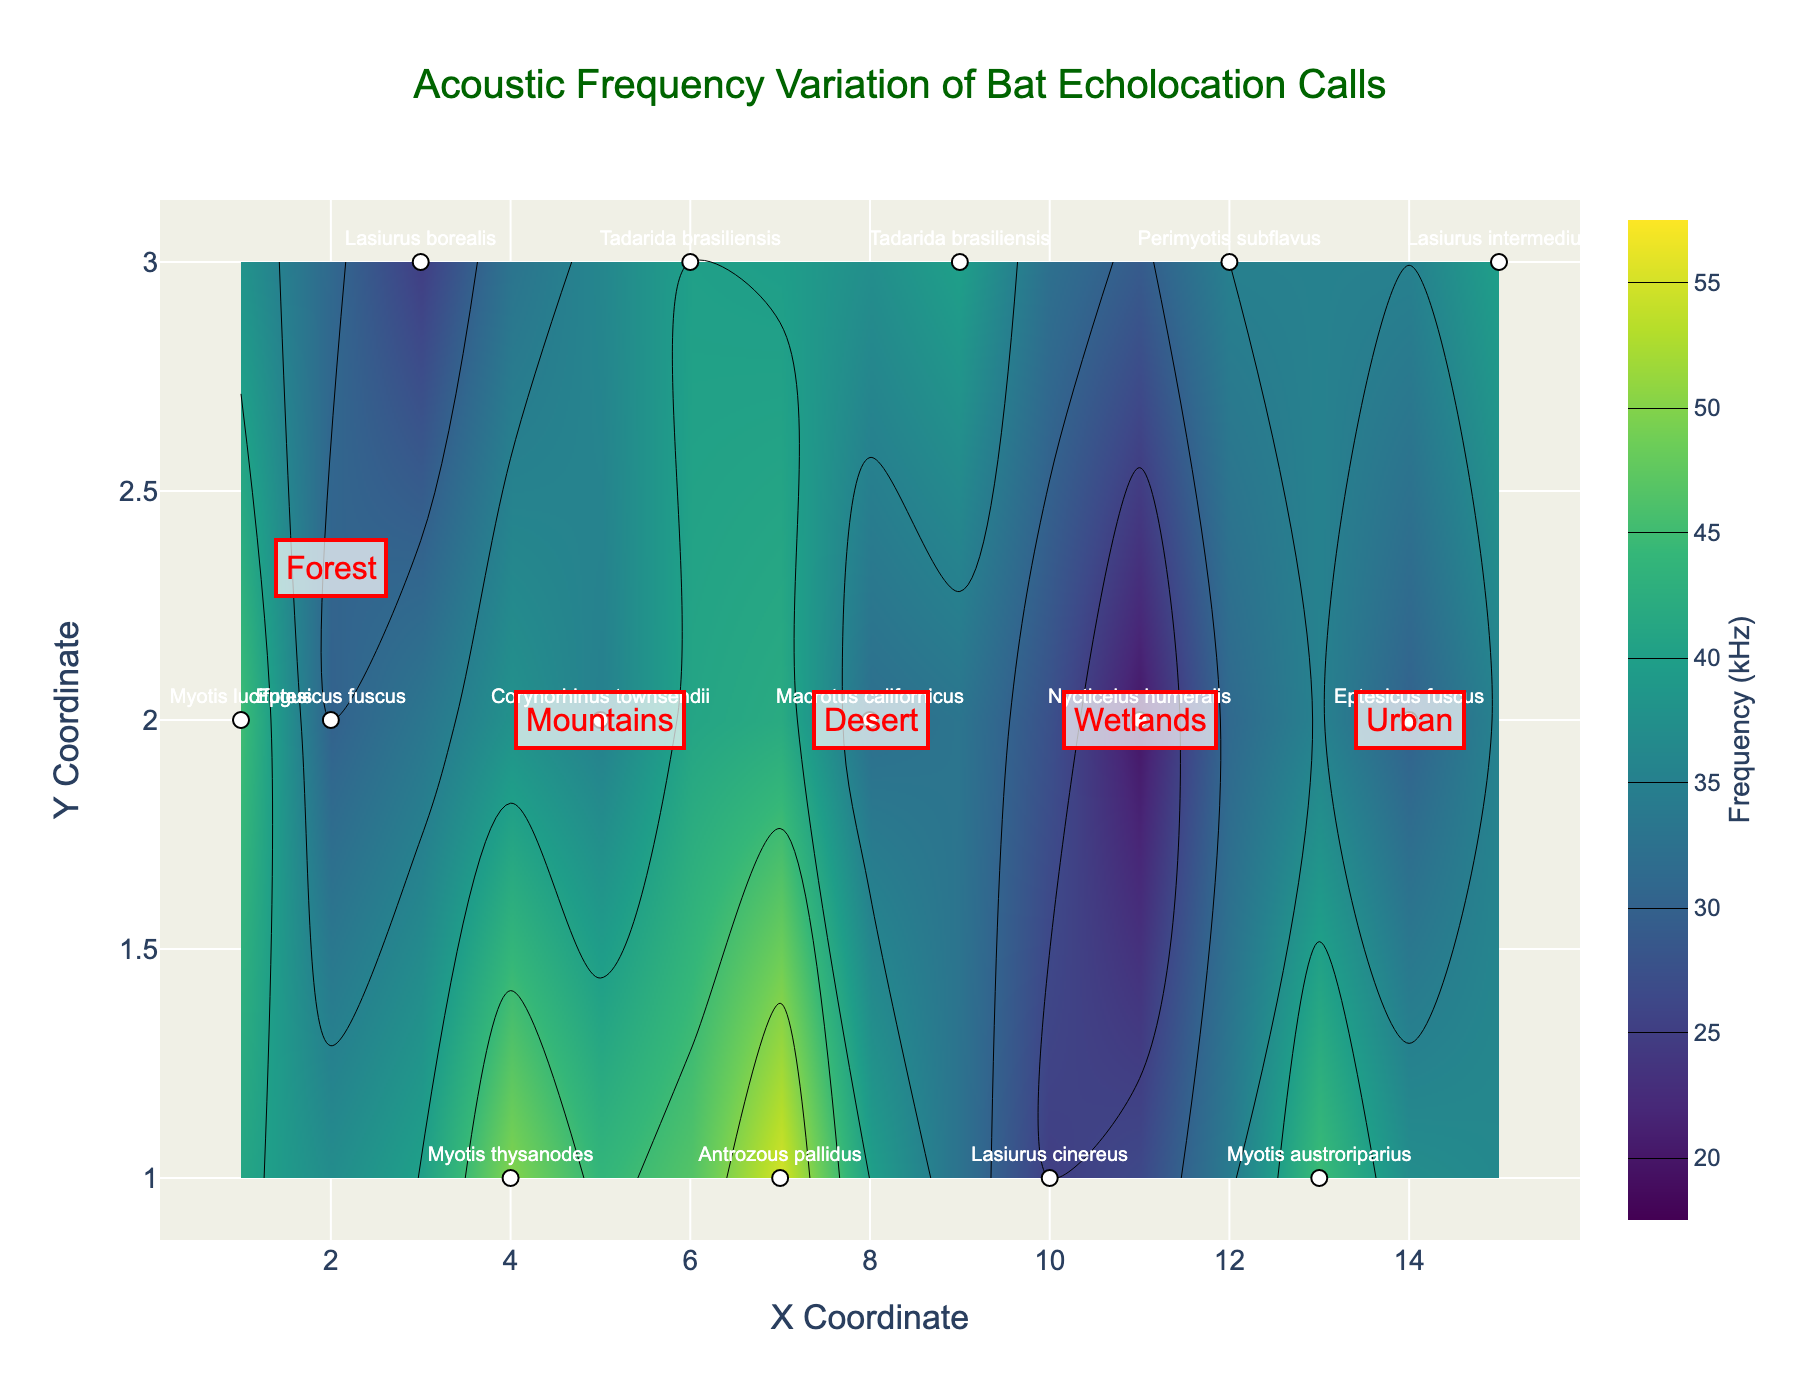What is the title of the figure? The title is located at the top center of the figure, often larger and bold compared to other text. It reads "Acoustic Frequency Variation of Bat Echolocation Calls".
Answer: Acoustic Frequency Variation of Bat Echolocation Calls What is the range of the colorbar? The colorbar is located on the right side of the figure, labeled "Frequency (kHz)", with ticks starting at 20 and ending at 55.
Answer: 20 to 55 kHz Which bat species has the highest acoustic frequency in the mountains terrain? Identify the Mountain region marked on the figure. The species with the highest frequency in this region is Myotis thysanodes, located at the top of the contour lines in this region.
Answer: Myotis thysanodes How many bat species are found in the desert terrain? Look for the Desert annotation in the figure. There are three bat species labeled within this region: Antrozous pallidus, Macrotus californicus, and Tadarida brasiliensis.
Answer: 3 What is the average acoustic frequency of the bat species in the wetlands terrain? Locate the Wetlands region. The frequencies are 25 kHz for Lasiurus cinereus, 20 kHz for Nycticeius humeralis, and 35 kHz for Perimyotis subflavus. Average = (25 + 20 + 35) / 3.
Answer: 26.67 kHz Which terrain has the most varied range of acoustic frequencies among bat species? Compare the range of frequencies in different terrains by looking at the spread of contour lines and the labeled frequencies. The Desert terrain shows a wide range from 32 to 55 kHz.
Answer: Desert Which species can be found in both the Mountains and Desert terrains? Identify the Desert and Mountains regions and compare species names. Tadarida brasiliensis is present in both regions.
Answer: Tadarida brasiliensis At which X and Y coordinates is the species Lasiurus borealis found? Locate the label for Lasiurus borealis in the Forest terrain. Its coordinates are (3, 3).
Answer: (3, 3) What is the difference in acoustic frequency between Eptesicus fuscus in the Forest and Urban terrains? Identify Eptesicus fuscus in both terrains. In the Forest, its frequency is 30 kHz, and in the Urban, it is also 30 kHz. Subtracting these gives zero.
Answer: 0 kHz 